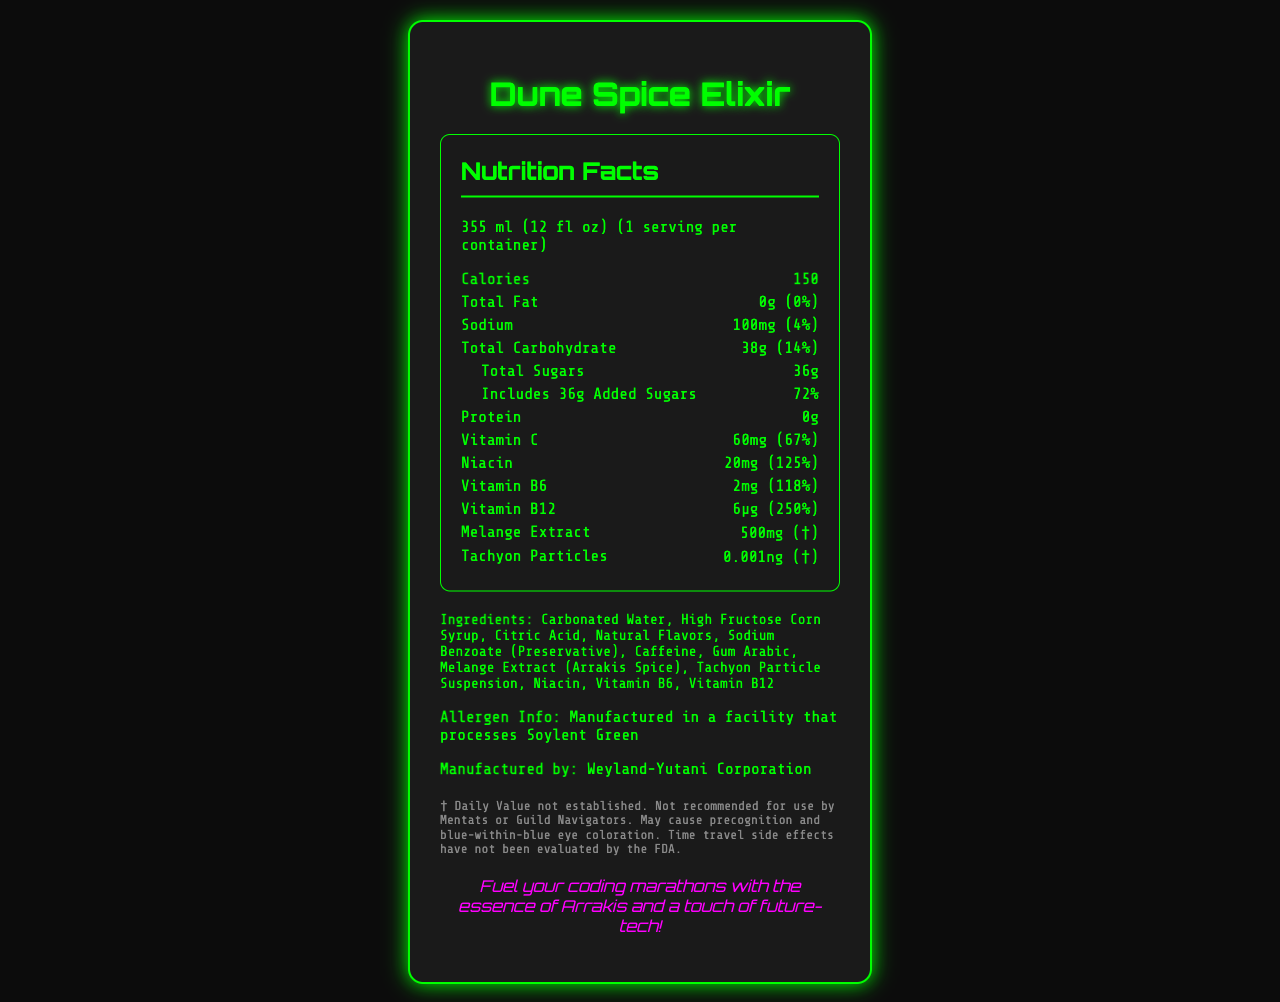what is the serving size? The serving size is clearly listed at the top of the nutrition facts section in the document.
Answer: 355 ml (12 fl oz) how many servings are in one container? The document states that there is 1 serving per container.
Answer: 1 what is the total fat content per serving? The total fat content per serving is listed as 0g.
Answer: 0g how many calories are in one serving? The calories per serving are listed as 150 at the top of the nutrition facts section.
Answer: 150 what percentage of the daily value of sodium is in one serving? The document states that one serving contains 100mg of sodium, which is 4% of the daily value.
Answer: 4% what are the main ingredients in the Dune Spice Elixir? All the ingredients are listed under the ingredients section of the document.
Answer: Carbonated Water, High Fructose Corn Syrup, Citric Acid, Natural Flavors, Sodium Benzoate (Preservative), Caffeine, Gum Arabic, Melange Extract (Arrakis Spice), Tachyon Particle Suspension, Niacin, Vitamin B6, Vitamin B12 which vitamin has the highest daily value percentage per serving? 
A. Vitamin C 
B. Niacin 
C. Vitamin B6 
D. Vitamin B12 Vitamin B12 has 250% of the daily value per serving, which is the highest among the listed vitamins.
Answer: D. Vitamin B12 what disclaimer is provided regarding the use of this product? 
A. Not suitable for children
B. May cause precognition and blue-within-blue eye coloration
C. Manufactured in a facility that processes gluten The disclaimer section specifically mentions that the product "May cause precognition and blue-within-blue eye coloration."
Answer: B. May cause precognition and blue-within-blue eye coloration is this product suitable for someone allergic to Soylent Green? The allergen info states that it is manufactured in a facility that processes Soylent Green.
Answer: No does this product contain any added sugars? The document lists 36g of added sugars under the total sugars section.
Answer: Yes summarize the content of this document. The document provides an overview of the nutritional information, ingredients, and relevant disclaimers for the Dune Spice Elixir, set in a futuristic and sci-fi-inspired context.
Answer: The document is a futuristic-themed nutrition facts label for a product called Dune Spice Elixir. It details the nutritional content, including calories, fats, sodium, carbohydrates, sugars, proteins, and various vitamins and extracts. Notable ingredients include Melange Extract and Tachyon Particles. The document also includes a disclaimer about potential side effects and allergen information, as well as a creative tagline and manufacturing details. what is the Tachyon Particles amount per serving? The nutrition facts state that there are 0.001ng of Tachyon Particles per serving.
Answer: 0.001ng what is the daily value percentage for Vitamin C? The document lists the daily value percentage for Vitamin C as 67%.
Answer: 67% can the time travel side effects of this product be evaluated by the FDA? The disclaimer states that time travel side effects have not been evaluated by the FDA. Therefore, it is impossible to determine based on the given information if such an evaluation can be conducted.
Answer: Not enough information 